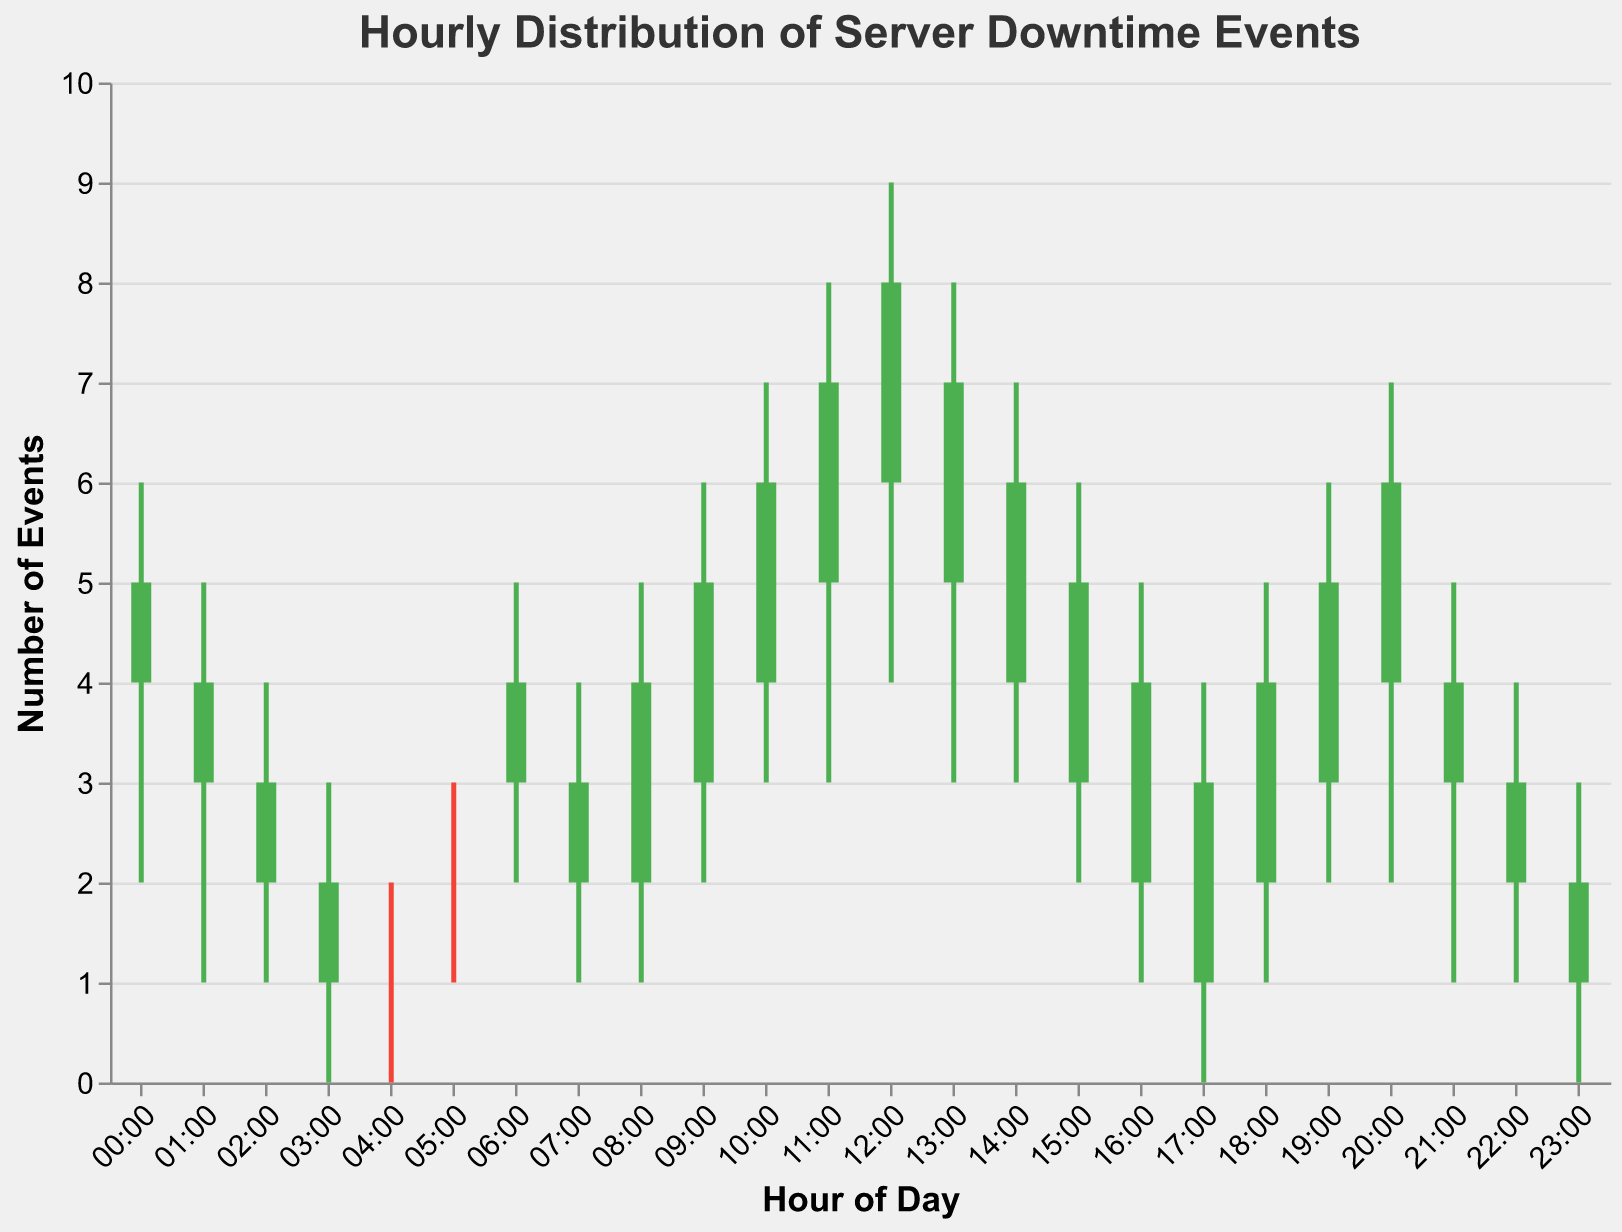Which hour had the highest number of server downtime events at its peak? The peak number of server downtime events can be identified by looking at the highest "High" value in the plot. The hour "12:00" has the highest "High" value of 9.
Answer: 12:00 What is the lowest number of server downtime events recorded and at what hour did it occur? The lowest number of server downtime events can be identified by looking at the lowest "Low" value in the plot, which is 0. This occurs at several hours: 03:00, 04:00, 17:00, and 23:00.
Answer: 0 at 03:00, 04:00, 17:00, 23:00 During which hour did the server downtimes increase compared to the previous hour? To see the increase, compare the "Close" value of one hour to the "Open" value of the next hour. From 23:00 (Close: 2) to 00:00 (Open: 4), there is an increase.
Answer: 00:00 Which hour experienced a fall in server downtime events but still had a higher "Close" value than its "Open" value? Identify the hours where the "Open" value is less than the "Close" value, and still, the overall downtime fell during that hour. For 17:00 (Open: 1, Close: 3, High: 4, Low: 0), there was a fall in the overall range but an increase from open to close.
Answer: 17:00 What is the average "Close" value for the server downtimes between 10:00 and 14:00? Sum of the "Close" values from 10:00 to 14:00 (6 + 7 + 8 + 7 + 6) divided by the number of hours (5). Calculations: (6 + 7 + 8 + 7 + 6) / 5 = 34 / 5 = 6.8
Answer: 6.8 Which hour had the smallest range of downtime events? The range is determined by subtracting the "Low" value from the "High" value. The smallest range (2 - 1 = 1) is seen at 04:00.
Answer: 04:00 During which hour was the change in downtime events the greatest? The greatest change can be identified by the largest difference between the "Open" and "Close" values. At 12:00 (Open: 6, Close: 8), the change is
Answer: 12:00 What trend do you observe in the downtimes from 00:00 to 04:00? From 00:00 to 04:00, both the "High" and "Low" values decrease progressively, indicating a downward trend in downtime events.
Answer: Downward trend 